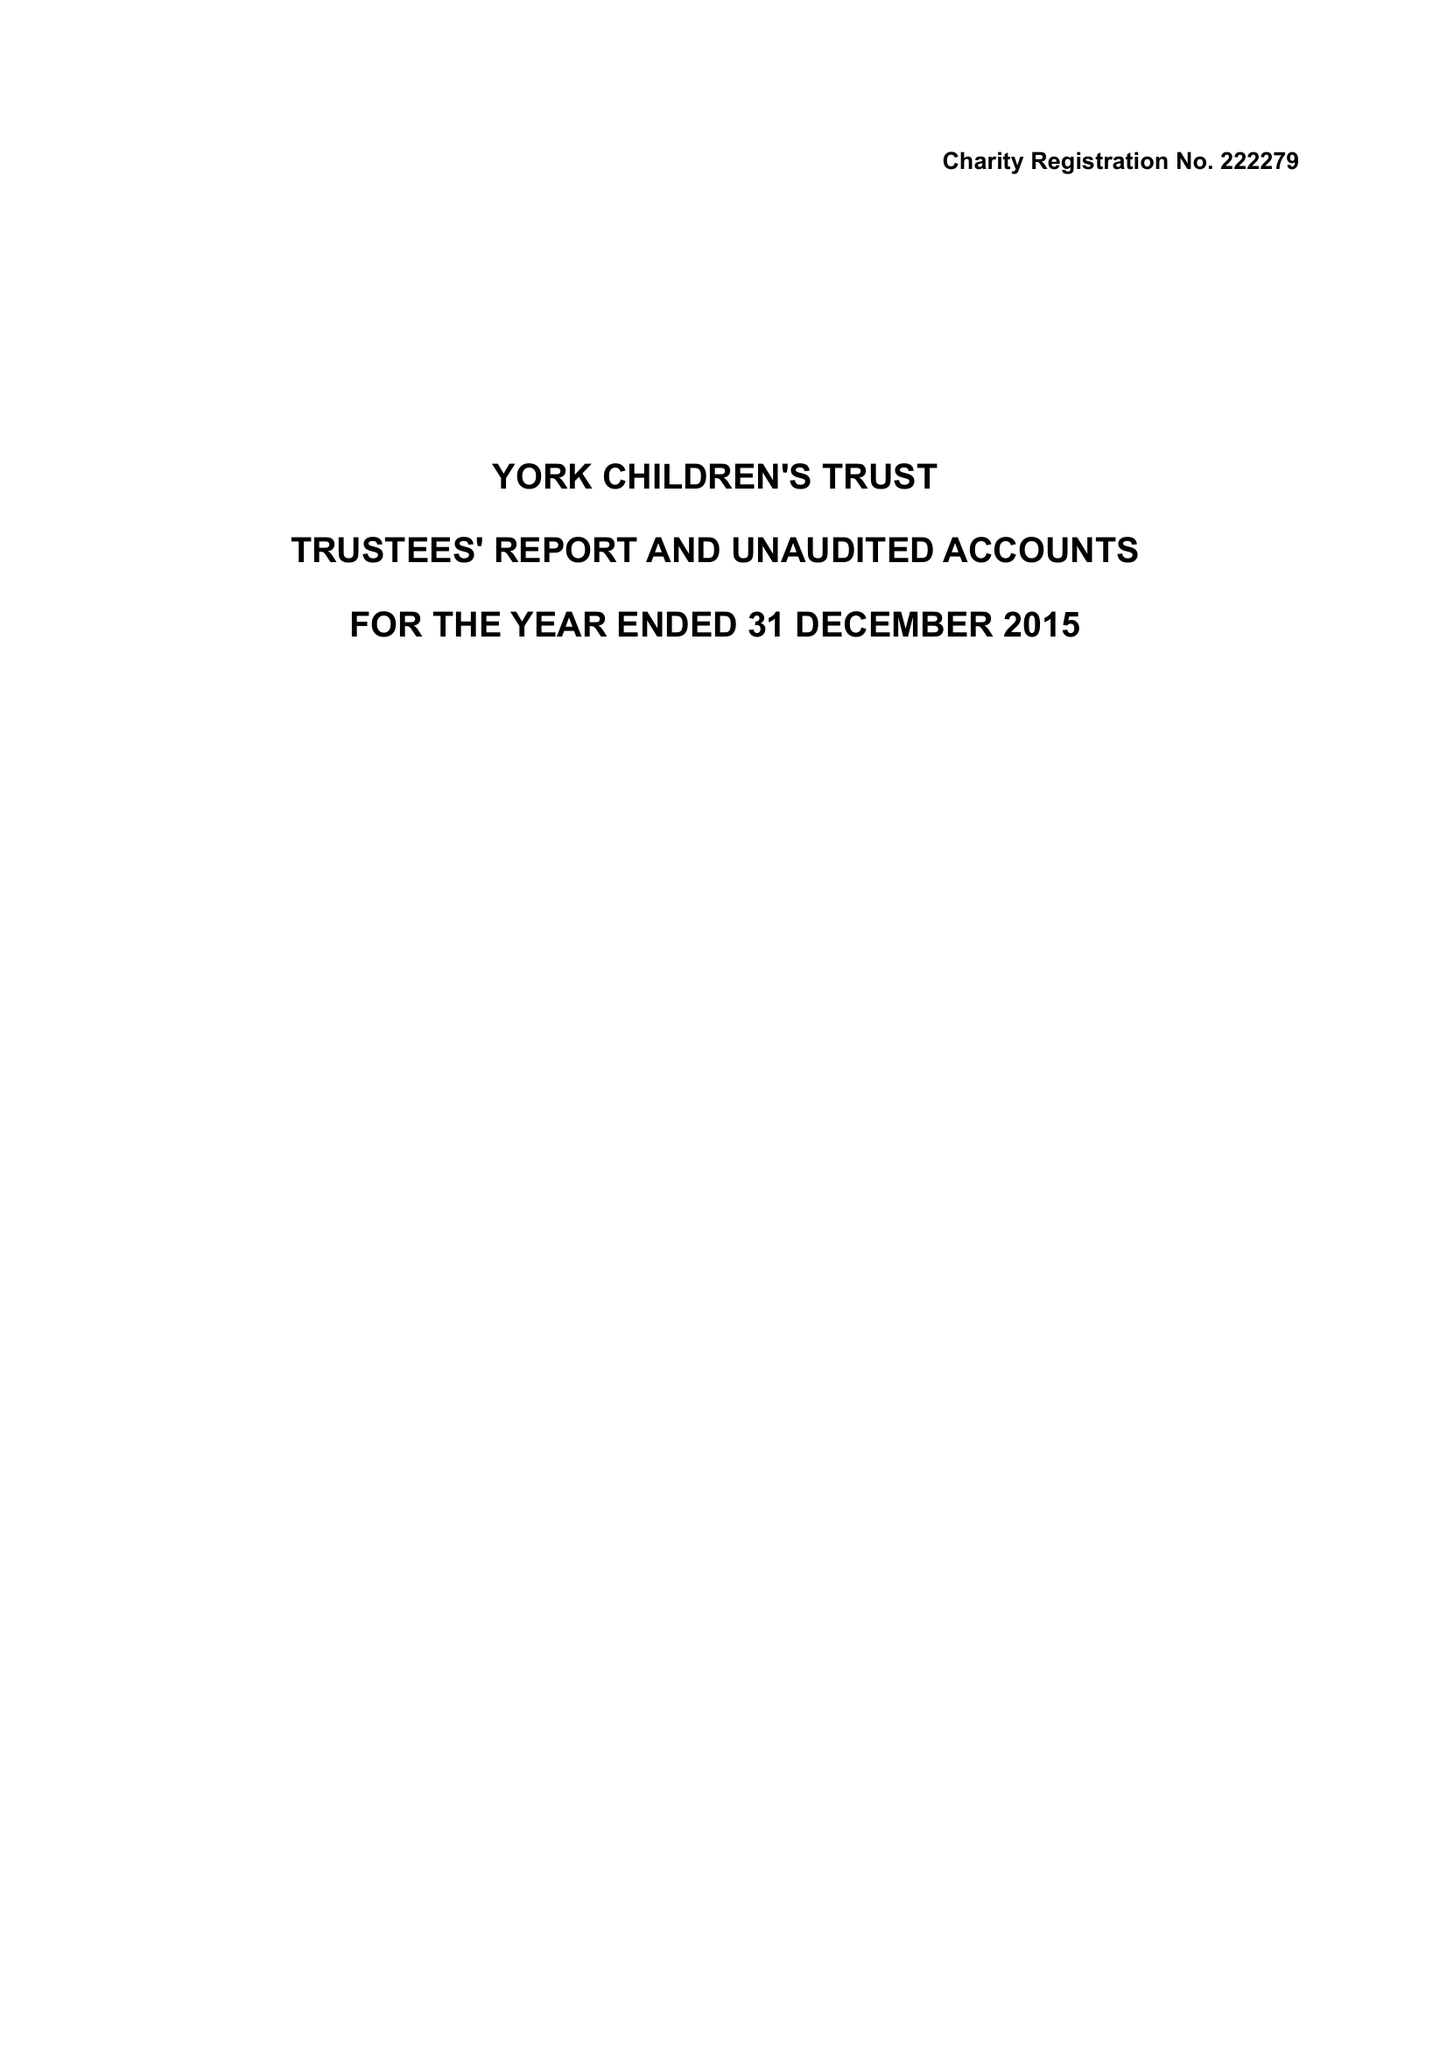What is the value for the report_date?
Answer the question using a single word or phrase. 2015-12-31 